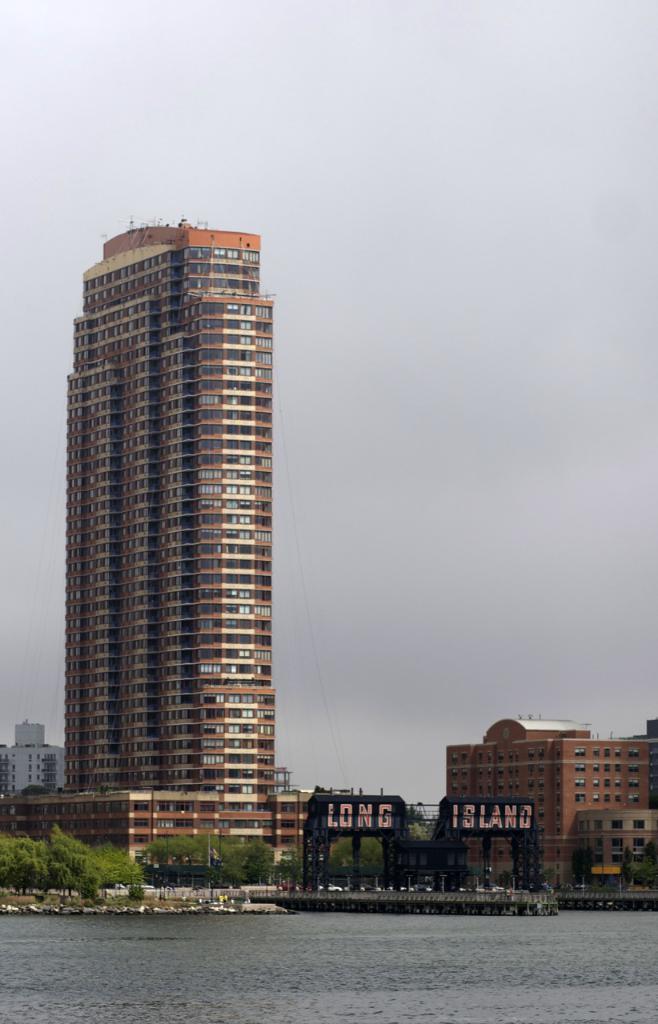In one or two sentences, can you explain what this image depicts? In the picture I can see buildings, trees, water and some other objects. In the background I can see the sky. 